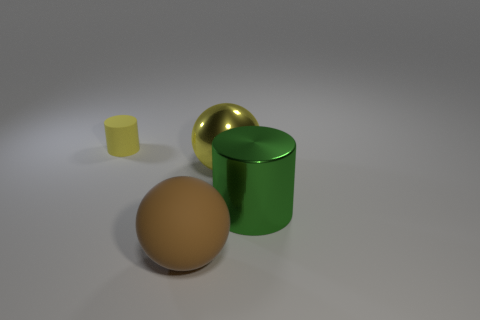What is the color of the sphere that is the same size as the brown thing?
Your answer should be compact. Yellow. What number of other brown matte objects are the same shape as the big rubber thing?
Your answer should be very brief. 0. How many cylinders are either tiny rubber objects or green things?
Give a very brief answer. 2. There is a matte thing to the left of the large brown sphere; is its shape the same as the green object right of the yellow rubber thing?
Ensure brevity in your answer.  Yes. What is the material of the yellow ball?
Offer a terse response. Metal. What shape is the metal object that is the same color as the matte cylinder?
Ensure brevity in your answer.  Sphere. What number of other spheres have the same size as the brown ball?
Give a very brief answer. 1. What number of things are big shiny things that are behind the large green object or rubber things that are behind the big brown thing?
Provide a short and direct response. 2. Is the material of the yellow object to the right of the small cylinder the same as the big thing on the right side of the big metal sphere?
Keep it short and to the point. Yes. There is a thing that is to the right of the yellow ball to the right of the yellow cylinder; what is its shape?
Ensure brevity in your answer.  Cylinder. 